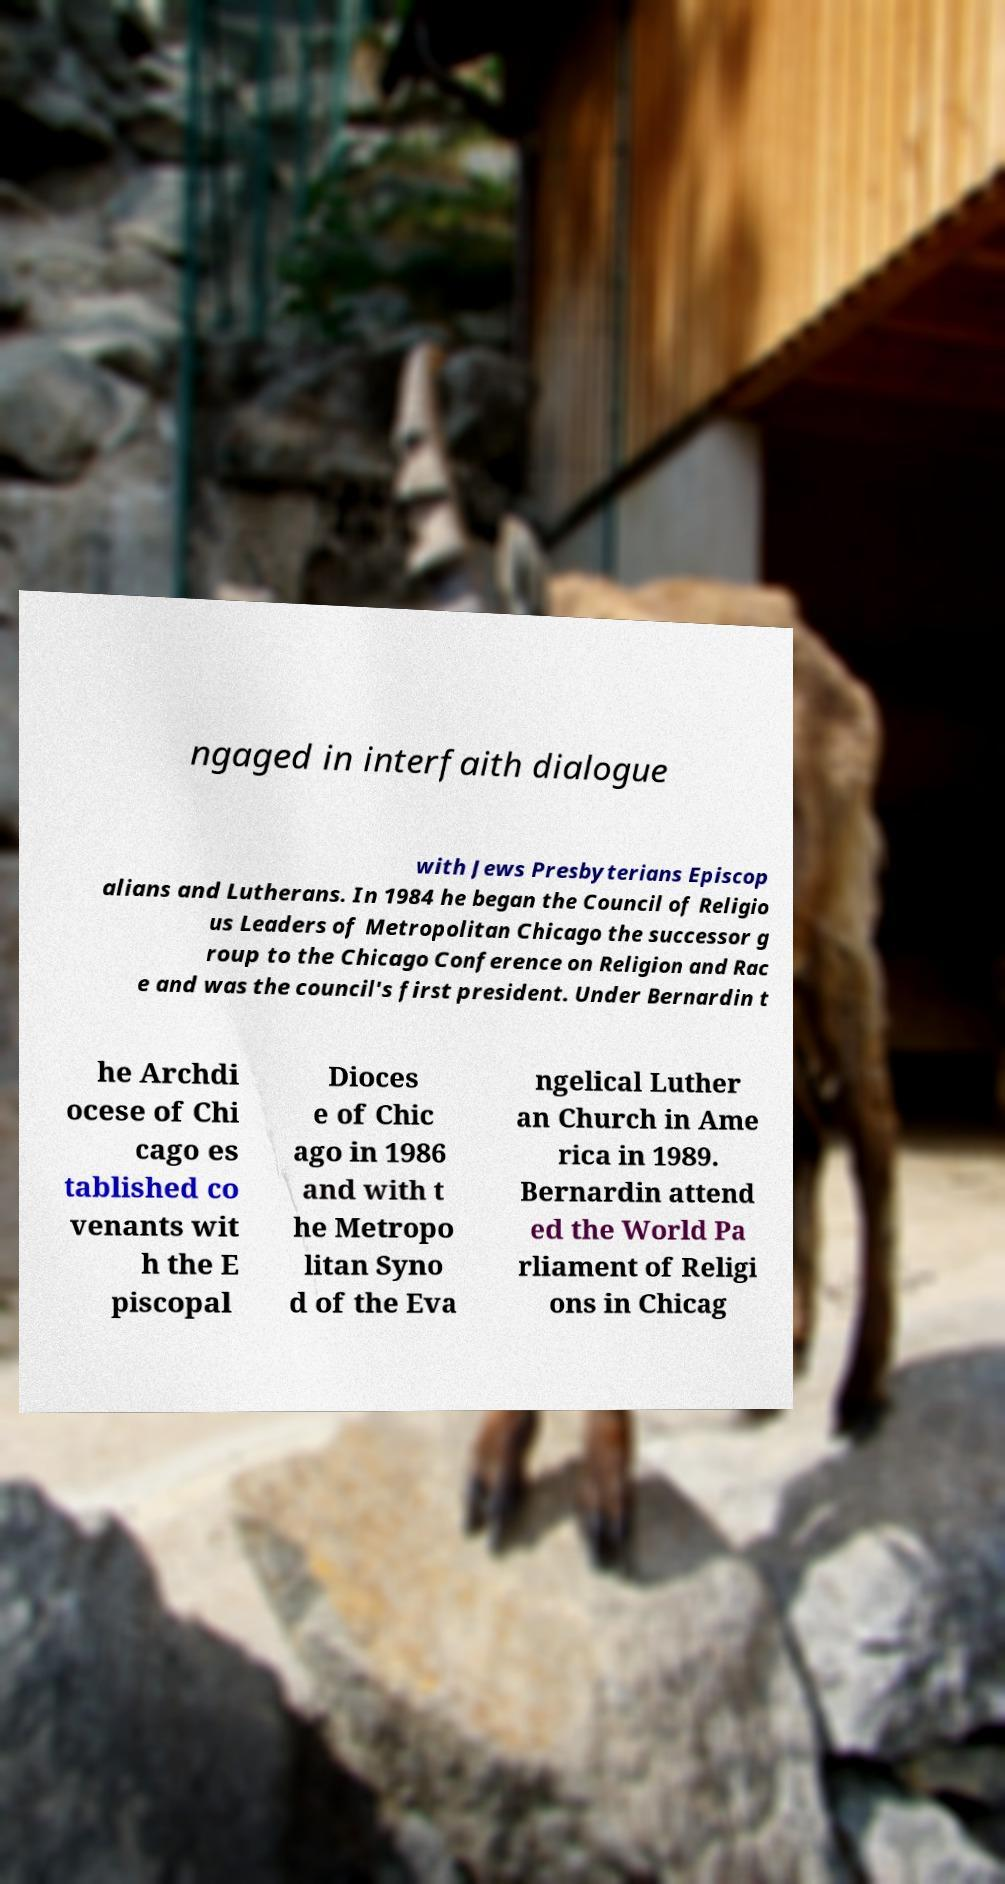What messages or text are displayed in this image? I need them in a readable, typed format. ngaged in interfaith dialogue with Jews Presbyterians Episcop alians and Lutherans. In 1984 he began the Council of Religio us Leaders of Metropolitan Chicago the successor g roup to the Chicago Conference on Religion and Rac e and was the council's first president. Under Bernardin t he Archdi ocese of Chi cago es tablished co venants wit h the E piscopal Dioces e of Chic ago in 1986 and with t he Metropo litan Syno d of the Eva ngelical Luther an Church in Ame rica in 1989. Bernardin attend ed the World Pa rliament of Religi ons in Chicag 